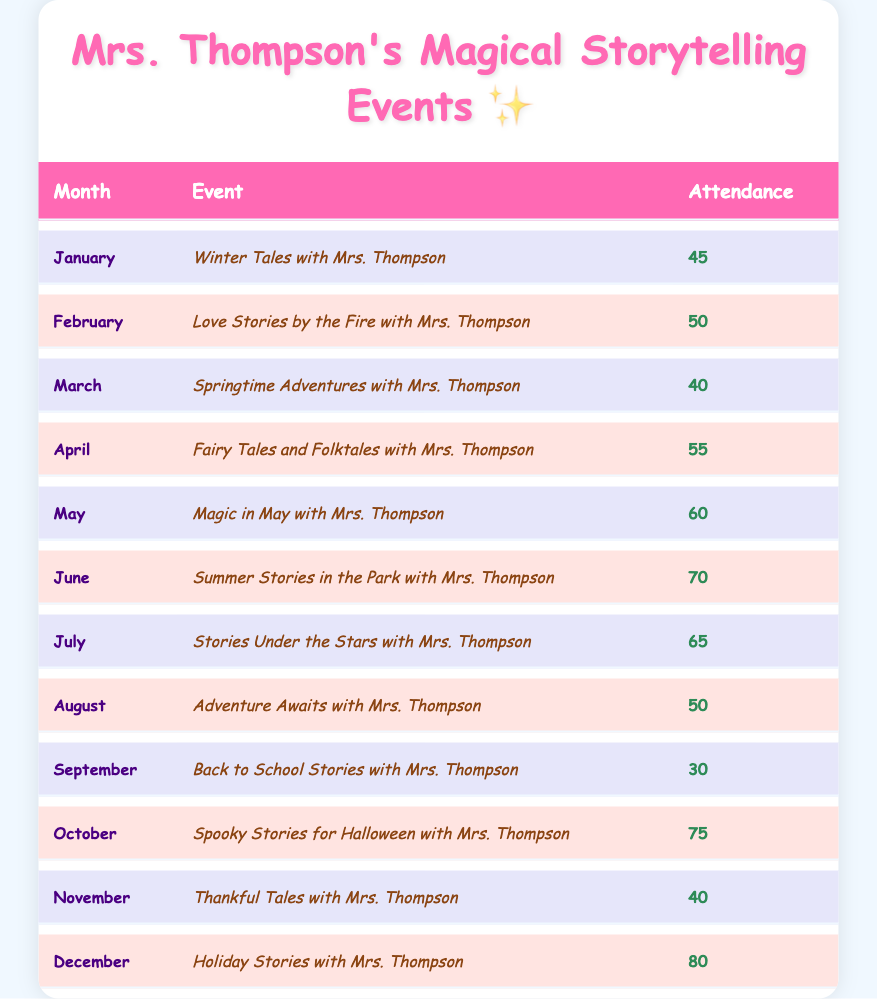What was the attendance for the event in June? You can find the month of June in the table and see the corresponding attendance. It shows that the attendance for June is 70.
Answer: 70 Which month had the highest attendance? By looking through all the attendance values in the table, you can see that December has the highest attendance of 80 compared to all other months.
Answer: December What is the average attendance for the events from January to December? To find the average, sum all the attendance values: 45 + 50 + 40 + 55 + 60 + 70 + 65 + 50 + 30 + 75 + 40 + 80 = 750. Then, divide by the number of months (12): 750 / 12 = 62.5.
Answer: 62.5 Did more people attend the "Spooky Stories for Halloween" event than the "Back to School Stories"? The attendance for "Spooky Stories for Halloween" is 75, while "Back to School Stories" has an attendance of 30. Since 75 is greater than 30, the answer is yes.
Answer: Yes How many more attendees were present in October compared to November? For October, the attendance is 75 and for November it is 40. To find the difference, subtract November's attendance from October's: 75 - 40 = 35.
Answer: 35 Which event had the least attendance in the year? By checking each month in the table, you can see that September had the least attendance of 30.
Answer: September Is it true that the attendance in March was greater than in April? The attendance for March is 40, and for April, it is 55. Since 40 is less than 55, the statement is false.
Answer: No Which two months had the highest combined attendance? To find out which two months had the highest combined attendance, examine the values. The highest attendance months are December (80) and October (75) giving a combined total of 80 + 75 = 155.
Answer: 155 